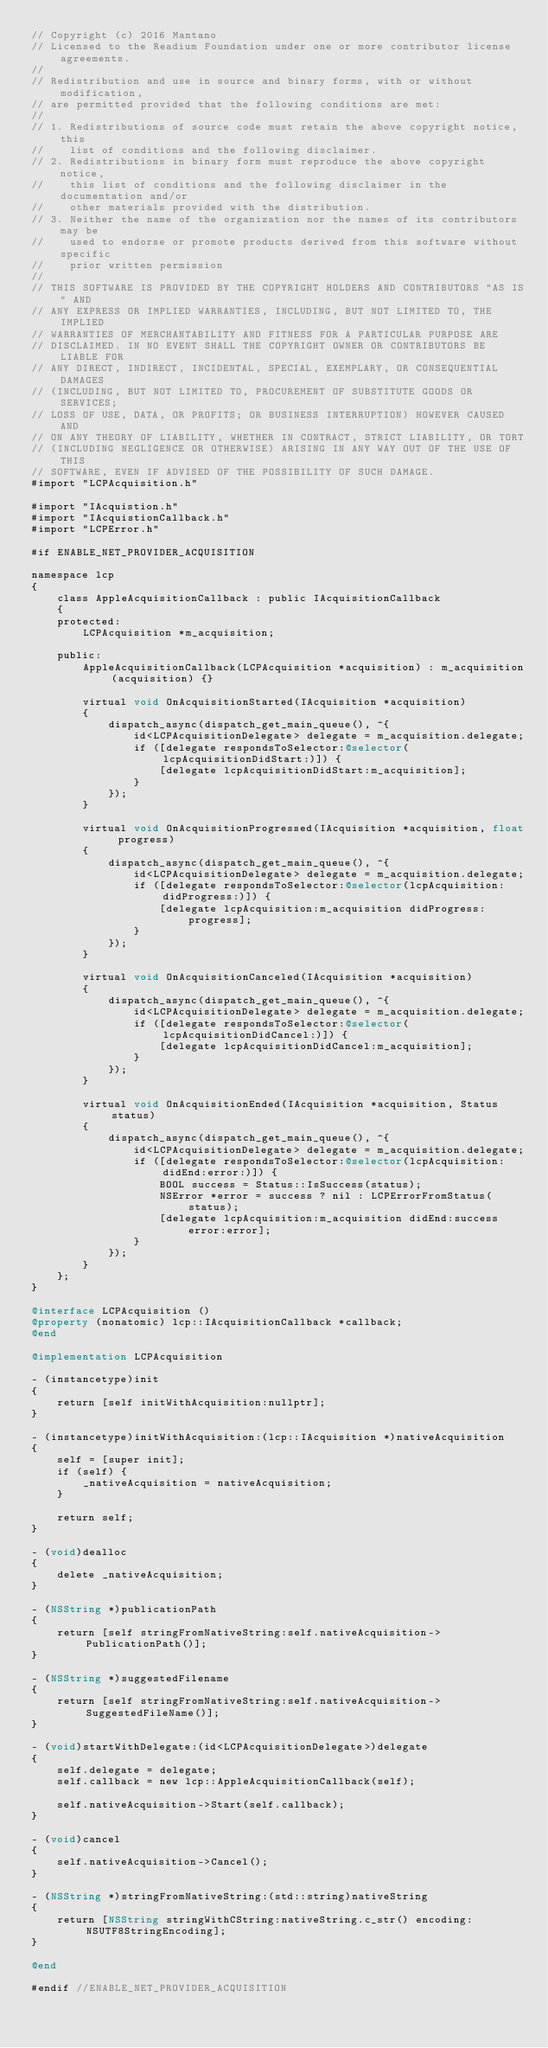<code> <loc_0><loc_0><loc_500><loc_500><_ObjectiveC_>// Copyright (c) 2016 Mantano
// Licensed to the Readium Foundation under one or more contributor license agreements.
//
// Redistribution and use in source and binary forms, with or without modification,
// are permitted provided that the following conditions are met:
//
// 1. Redistributions of source code must retain the above copyright notice, this
//    list of conditions and the following disclaimer.
// 2. Redistributions in binary form must reproduce the above copyright notice,
//    this list of conditions and the following disclaimer in the documentation and/or
//    other materials provided with the distribution.
// 3. Neither the name of the organization nor the names of its contributors may be
//    used to endorse or promote products derived from this software without specific
//    prior written permission
//
// THIS SOFTWARE IS PROVIDED BY THE COPYRIGHT HOLDERS AND CONTRIBUTORS "AS IS" AND
// ANY EXPRESS OR IMPLIED WARRANTIES, INCLUDING, BUT NOT LIMITED TO, THE IMPLIED
// WARRANTIES OF MERCHANTABILITY AND FITNESS FOR A PARTICULAR PURPOSE ARE
// DISCLAIMED. IN NO EVENT SHALL THE COPYRIGHT OWNER OR CONTRIBUTORS BE LIABLE FOR
// ANY DIRECT, INDIRECT, INCIDENTAL, SPECIAL, EXEMPLARY, OR CONSEQUENTIAL DAMAGES
// (INCLUDING, BUT NOT LIMITED TO, PROCUREMENT OF SUBSTITUTE GOODS OR SERVICES;
// LOSS OF USE, DATA, OR PROFITS; OR BUSINESS INTERRUPTION) HOWEVER CAUSED AND
// ON ANY THEORY OF LIABILITY, WHETHER IN CONTRACT, STRICT LIABILITY, OR TORT
// (INCLUDING NEGLIGENCE OR OTHERWISE) ARISING IN ANY WAY OUT OF THE USE OF THIS
// SOFTWARE, EVEN IF ADVISED OF THE POSSIBILITY OF SUCH DAMAGE.
#import "LCPAcquisition.h"

#import "IAcquistion.h"
#import "IAcquistionCallback.h"
#import "LCPError.h"

#if ENABLE_NET_PROVIDER_ACQUISITION

namespace lcp
{
    class AppleAcquisitionCallback : public IAcquisitionCallback
    {
    protected:
        LCPAcquisition *m_acquisition;
        
    public:
        AppleAcquisitionCallback(LCPAcquisition *acquisition) : m_acquisition(acquisition) {}
        
        virtual void OnAcquisitionStarted(IAcquisition *acquisition)
        {
            dispatch_async(dispatch_get_main_queue(), ^{
                id<LCPAcquisitionDelegate> delegate = m_acquisition.delegate;
                if ([delegate respondsToSelector:@selector(lcpAcquisitionDidStart:)]) {
                    [delegate lcpAcquisitionDidStart:m_acquisition];
                }
            });
        }
        
        virtual void OnAcquisitionProgressed(IAcquisition *acquisition, float progress)
        {
            dispatch_async(dispatch_get_main_queue(), ^{
                id<LCPAcquisitionDelegate> delegate = m_acquisition.delegate;
                if ([delegate respondsToSelector:@selector(lcpAcquisition:didProgress:)]) {
                    [delegate lcpAcquisition:m_acquisition didProgress:progress];
                }
            });
        }
        
        virtual void OnAcquisitionCanceled(IAcquisition *acquisition)
        {
            dispatch_async(dispatch_get_main_queue(), ^{
                id<LCPAcquisitionDelegate> delegate = m_acquisition.delegate;
                if ([delegate respondsToSelector:@selector(lcpAcquisitionDidCancel:)]) {
                    [delegate lcpAcquisitionDidCancel:m_acquisition];
                }
            });
        }
        
        virtual void OnAcquisitionEnded(IAcquisition *acquisition, Status status)
        {
            dispatch_async(dispatch_get_main_queue(), ^{
                id<LCPAcquisitionDelegate> delegate = m_acquisition.delegate;
                if ([delegate respondsToSelector:@selector(lcpAcquisition:didEnd:error:)]) {
                    BOOL success = Status::IsSuccess(status);
                    NSError *error = success ? nil : LCPErrorFromStatus(status);
                    [delegate lcpAcquisition:m_acquisition didEnd:success error:error];
                }
            });
        }
    };
}

@interface LCPAcquisition ()
@property (nonatomic) lcp::IAcquisitionCallback *callback;
@end

@implementation LCPAcquisition

- (instancetype)init
{
    return [self initWithAcquisition:nullptr];
}

- (instancetype)initWithAcquisition:(lcp::IAcquisition *)nativeAcquisition
{
    self = [super init];
    if (self) {
        _nativeAcquisition = nativeAcquisition;
    }
    
    return self;
}

- (void)dealloc
{
    delete _nativeAcquisition;
}

- (NSString *)publicationPath
{
    return [self stringFromNativeString:self.nativeAcquisition->PublicationPath()];
}

- (NSString *)suggestedFilename
{
    return [self stringFromNativeString:self.nativeAcquisition->SuggestedFileName()];
}

- (void)startWithDelegate:(id<LCPAcquisitionDelegate>)delegate
{
    self.delegate = delegate;
    self.callback = new lcp::AppleAcquisitionCallback(self);
    
    self.nativeAcquisition->Start(self.callback);
}

- (void)cancel
{
    self.nativeAcquisition->Cancel();
}

- (NSString *)stringFromNativeString:(std::string)nativeString
{
    return [NSString stringWithCString:nativeString.c_str() encoding:NSUTF8StringEncoding];
}

@end

#endif //ENABLE_NET_PROVIDER_ACQUISITION
</code> 